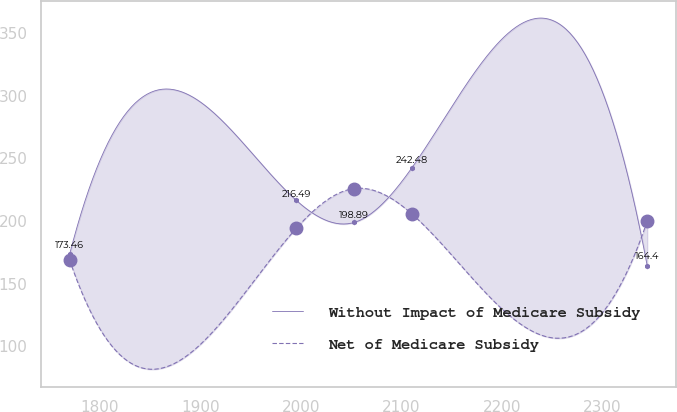Convert chart to OTSL. <chart><loc_0><loc_0><loc_500><loc_500><line_chart><ecel><fcel>Without Impact of Medicare Subsidy<fcel>Net of Medicare Subsidy<nl><fcel>1769.9<fcel>173.46<fcel>168.98<nl><fcel>1995.59<fcel>216.49<fcel>194.3<nl><fcel>2053.08<fcel>198.89<fcel>225.94<nl><fcel>2110.57<fcel>242.48<fcel>205.7<nl><fcel>2344.8<fcel>164.4<fcel>200<nl></chart> 